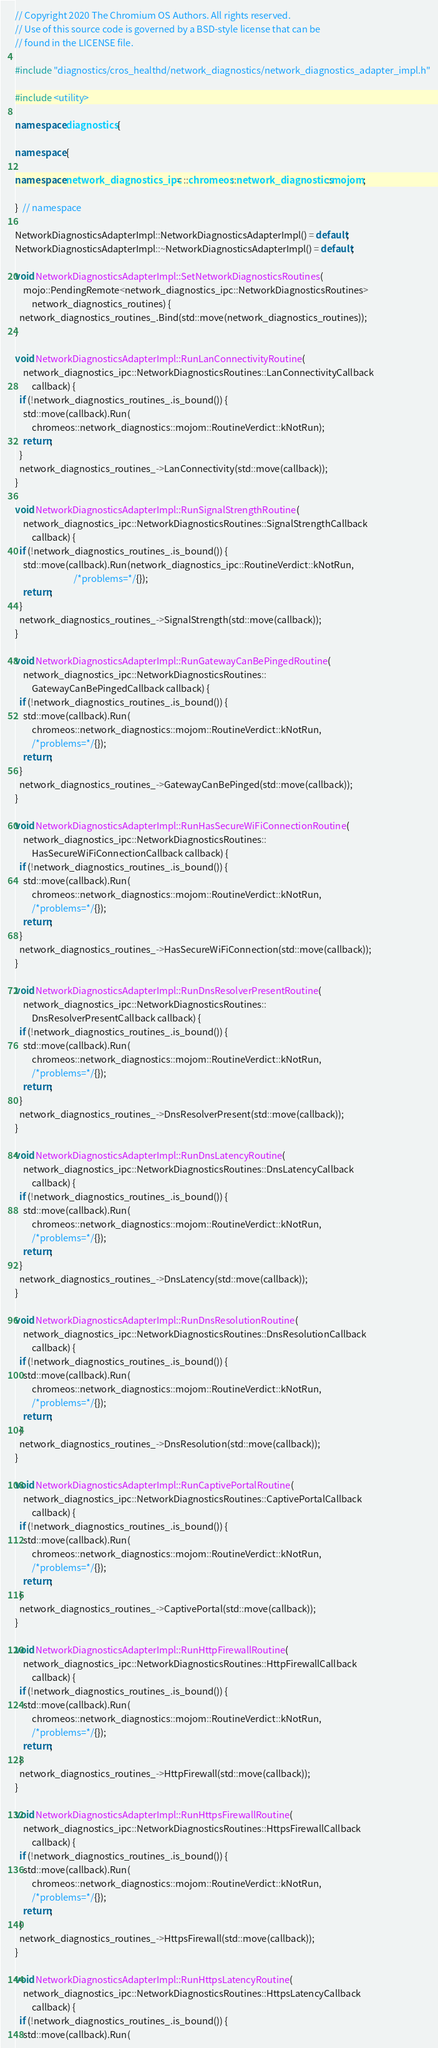Convert code to text. <code><loc_0><loc_0><loc_500><loc_500><_C++_>// Copyright 2020 The Chromium OS Authors. All rights reserved.
// Use of this source code is governed by a BSD-style license that can be
// found in the LICENSE file.

#include "diagnostics/cros_healthd/network_diagnostics/network_diagnostics_adapter_impl.h"

#include <utility>

namespace diagnostics {

namespace {

namespace network_diagnostics_ipc = ::chromeos::network_diagnostics::mojom;

}  // namespace

NetworkDiagnosticsAdapterImpl::NetworkDiagnosticsAdapterImpl() = default;
NetworkDiagnosticsAdapterImpl::~NetworkDiagnosticsAdapterImpl() = default;

void NetworkDiagnosticsAdapterImpl::SetNetworkDiagnosticsRoutines(
    mojo::PendingRemote<network_diagnostics_ipc::NetworkDiagnosticsRoutines>
        network_diagnostics_routines) {
  network_diagnostics_routines_.Bind(std::move(network_diagnostics_routines));
}

void NetworkDiagnosticsAdapterImpl::RunLanConnectivityRoutine(
    network_diagnostics_ipc::NetworkDiagnosticsRoutines::LanConnectivityCallback
        callback) {
  if (!network_diagnostics_routines_.is_bound()) {
    std::move(callback).Run(
        chromeos::network_diagnostics::mojom::RoutineVerdict::kNotRun);
    return;
  }
  network_diagnostics_routines_->LanConnectivity(std::move(callback));
}

void NetworkDiagnosticsAdapterImpl::RunSignalStrengthRoutine(
    network_diagnostics_ipc::NetworkDiagnosticsRoutines::SignalStrengthCallback
        callback) {
  if (!network_diagnostics_routines_.is_bound()) {
    std::move(callback).Run(network_diagnostics_ipc::RoutineVerdict::kNotRun,
                            /*problems=*/{});
    return;
  }
  network_diagnostics_routines_->SignalStrength(std::move(callback));
}

void NetworkDiagnosticsAdapterImpl::RunGatewayCanBePingedRoutine(
    network_diagnostics_ipc::NetworkDiagnosticsRoutines::
        GatewayCanBePingedCallback callback) {
  if (!network_diagnostics_routines_.is_bound()) {
    std::move(callback).Run(
        chromeos::network_diagnostics::mojom::RoutineVerdict::kNotRun,
        /*problems=*/{});
    return;
  }
  network_diagnostics_routines_->GatewayCanBePinged(std::move(callback));
}

void NetworkDiagnosticsAdapterImpl::RunHasSecureWiFiConnectionRoutine(
    network_diagnostics_ipc::NetworkDiagnosticsRoutines::
        HasSecureWiFiConnectionCallback callback) {
  if (!network_diagnostics_routines_.is_bound()) {
    std::move(callback).Run(
        chromeos::network_diagnostics::mojom::RoutineVerdict::kNotRun,
        /*problems=*/{});
    return;
  }
  network_diagnostics_routines_->HasSecureWiFiConnection(std::move(callback));
}

void NetworkDiagnosticsAdapterImpl::RunDnsResolverPresentRoutine(
    network_diagnostics_ipc::NetworkDiagnosticsRoutines::
        DnsResolverPresentCallback callback) {
  if (!network_diagnostics_routines_.is_bound()) {
    std::move(callback).Run(
        chromeos::network_diagnostics::mojom::RoutineVerdict::kNotRun,
        /*problems=*/{});
    return;
  }
  network_diagnostics_routines_->DnsResolverPresent(std::move(callback));
}

void NetworkDiagnosticsAdapterImpl::RunDnsLatencyRoutine(
    network_diagnostics_ipc::NetworkDiagnosticsRoutines::DnsLatencyCallback
        callback) {
  if (!network_diagnostics_routines_.is_bound()) {
    std::move(callback).Run(
        chromeos::network_diagnostics::mojom::RoutineVerdict::kNotRun,
        /*problems=*/{});
    return;
  }
  network_diagnostics_routines_->DnsLatency(std::move(callback));
}

void NetworkDiagnosticsAdapterImpl::RunDnsResolutionRoutine(
    network_diagnostics_ipc::NetworkDiagnosticsRoutines::DnsResolutionCallback
        callback) {
  if (!network_diagnostics_routines_.is_bound()) {
    std::move(callback).Run(
        chromeos::network_diagnostics::mojom::RoutineVerdict::kNotRun,
        /*problems=*/{});
    return;
  }
  network_diagnostics_routines_->DnsResolution(std::move(callback));
}

void NetworkDiagnosticsAdapterImpl::RunCaptivePortalRoutine(
    network_diagnostics_ipc::NetworkDiagnosticsRoutines::CaptivePortalCallback
        callback) {
  if (!network_diagnostics_routines_.is_bound()) {
    std::move(callback).Run(
        chromeos::network_diagnostics::mojom::RoutineVerdict::kNotRun,
        /*problems=*/{});
    return;
  }
  network_diagnostics_routines_->CaptivePortal(std::move(callback));
}

void NetworkDiagnosticsAdapterImpl::RunHttpFirewallRoutine(
    network_diagnostics_ipc::NetworkDiagnosticsRoutines::HttpFirewallCallback
        callback) {
  if (!network_diagnostics_routines_.is_bound()) {
    std::move(callback).Run(
        chromeos::network_diagnostics::mojom::RoutineVerdict::kNotRun,
        /*problems=*/{});
    return;
  }
  network_diagnostics_routines_->HttpFirewall(std::move(callback));
}

void NetworkDiagnosticsAdapterImpl::RunHttpsFirewallRoutine(
    network_diagnostics_ipc::NetworkDiagnosticsRoutines::HttpsFirewallCallback
        callback) {
  if (!network_diagnostics_routines_.is_bound()) {
    std::move(callback).Run(
        chromeos::network_diagnostics::mojom::RoutineVerdict::kNotRun,
        /*problems=*/{});
    return;
  }
  network_diagnostics_routines_->HttpsFirewall(std::move(callback));
}

void NetworkDiagnosticsAdapterImpl::RunHttpsLatencyRoutine(
    network_diagnostics_ipc::NetworkDiagnosticsRoutines::HttpsLatencyCallback
        callback) {
  if (!network_diagnostics_routines_.is_bound()) {
    std::move(callback).Run(</code> 